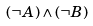<formula> <loc_0><loc_0><loc_500><loc_500>( \neg A ) \wedge ( \neg B )</formula> 